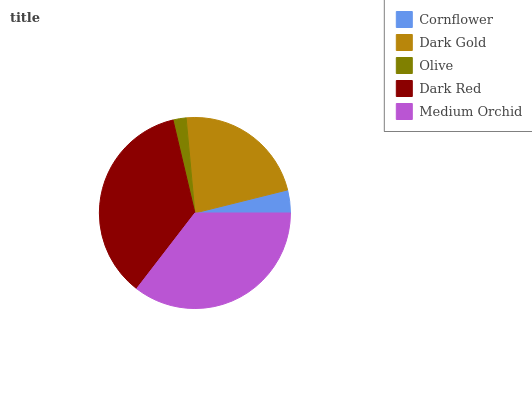Is Olive the minimum?
Answer yes or no. Yes. Is Dark Red the maximum?
Answer yes or no. Yes. Is Dark Gold the minimum?
Answer yes or no. No. Is Dark Gold the maximum?
Answer yes or no. No. Is Dark Gold greater than Cornflower?
Answer yes or no. Yes. Is Cornflower less than Dark Gold?
Answer yes or no. Yes. Is Cornflower greater than Dark Gold?
Answer yes or no. No. Is Dark Gold less than Cornflower?
Answer yes or no. No. Is Dark Gold the high median?
Answer yes or no. Yes. Is Dark Gold the low median?
Answer yes or no. Yes. Is Medium Orchid the high median?
Answer yes or no. No. Is Medium Orchid the low median?
Answer yes or no. No. 